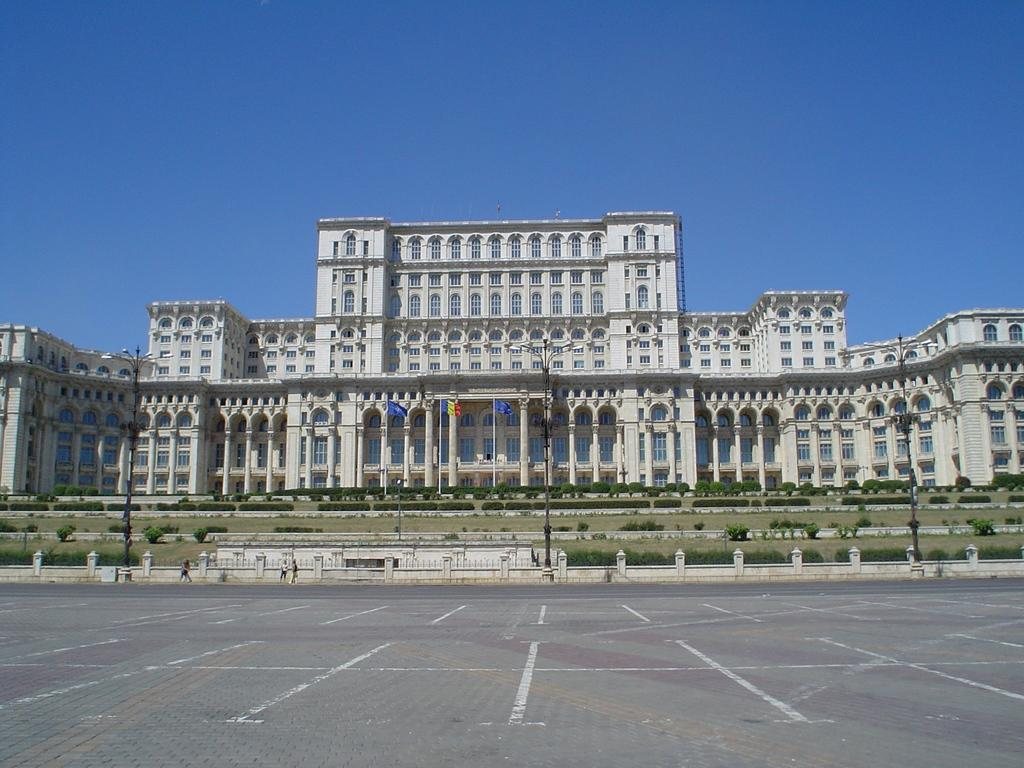What type of structures can be seen in the image? There are buildings in the image. What architectural features are present on the buildings? There are windows and pillars visible on the buildings. What type of lighting is present in the image? There are light poles in the image. What type of decorations are present in the image? There are flags in the image. What type of vegetation is present in the image? There are plants in the image. Are there any people visible in the image? Yes, there are people in the image. What part of the natural environment is visible in the image? The sky is visible in the image. What type of poison is being used to protest against the buildings in the image? There is no protest or poison present in the image; it features buildings, windows, pillars, light poles, flags, plants, and people. 